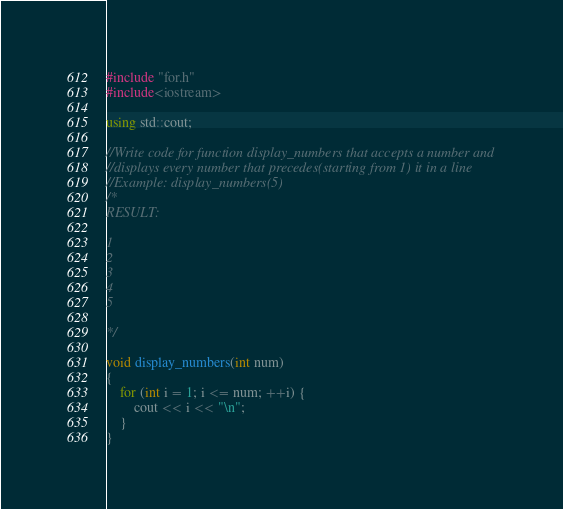<code> <loc_0><loc_0><loc_500><loc_500><_C++_>#include "for.h"
#include<iostream>

using std::cout;

//Write code for function display_numbers that accepts a number and 
//displays every number that precedes(starting from 1) it in a line
//Example: display_numbers(5)
/*
RESULT:

1
2
3
4
5

*/

void display_numbers(int num)
{
	for (int i = 1; i <= num; ++i) {
		cout << i << "\n";
	}
}
</code> 